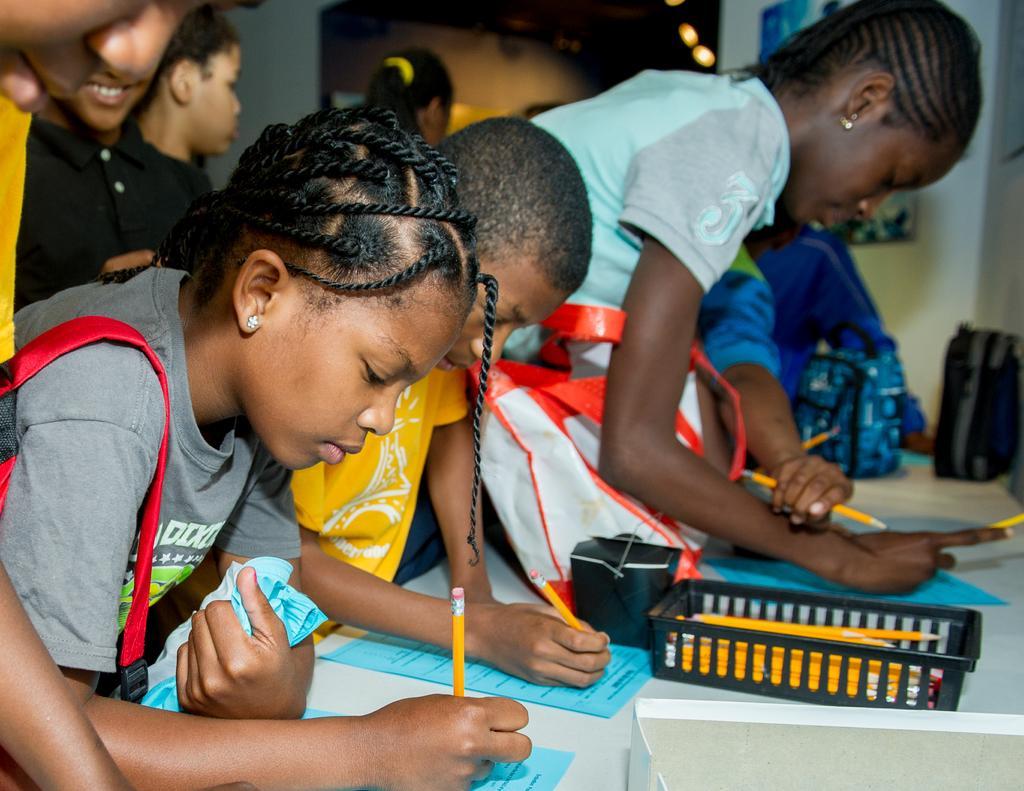Could you give a brief overview of what you see in this image? In this image there are group of people holding pencils and writing some thing on the papers, and there are bags, box, pencils in a tray, and in the background there are lights and frames attached to the wall. 